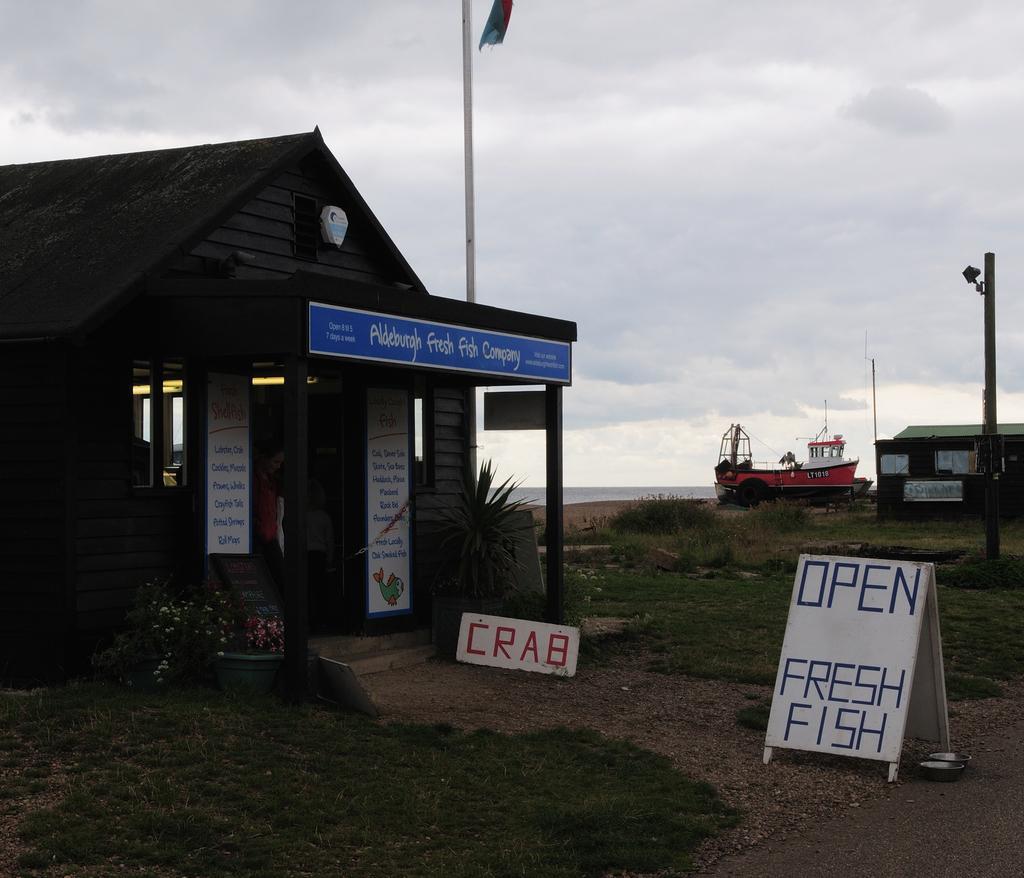Can you describe this image briefly? In this image I can see a board, grass, houseplants, houses and flagpole. In the background I can see a boat. On the top I can see the sky. This image is taken during a day. 